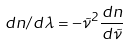Convert formula to latex. <formula><loc_0><loc_0><loc_500><loc_500>d n / d \lambda = - \tilde { \nu } ^ { 2 } \frac { d n } { d \tilde { \nu } }</formula> 